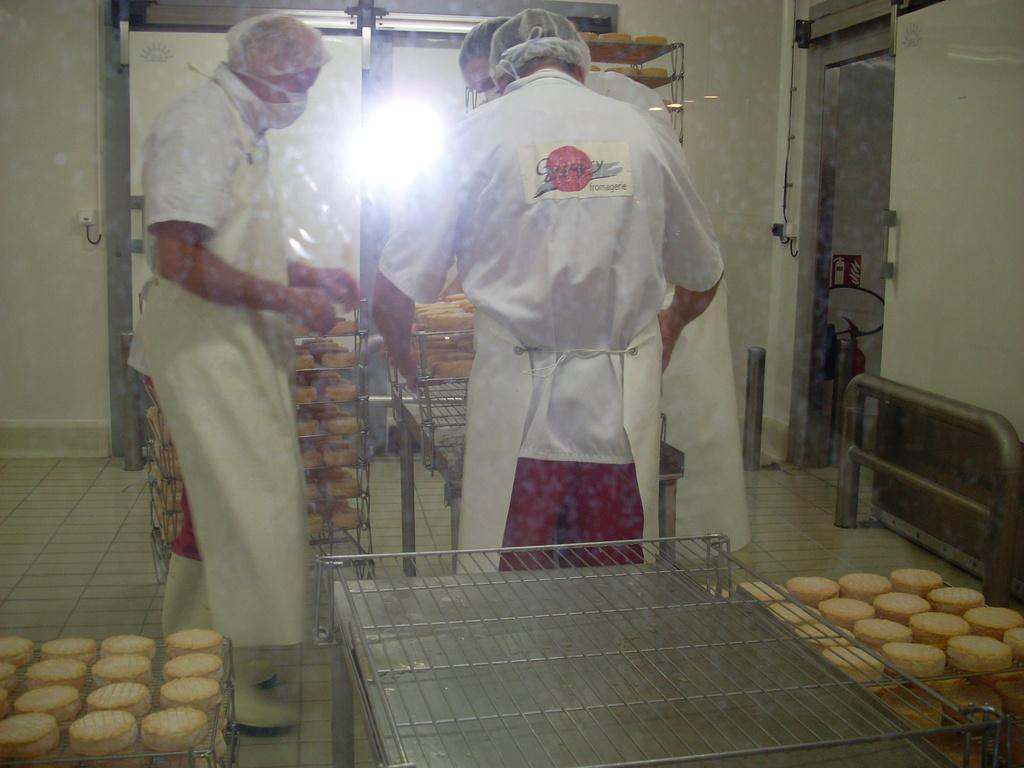In one or two sentences, can you explain what this image depicts? In this picture there are three men wearing white coats. At the bottom, there are trays with cookies. At the top right, there is a door to a wall. Behind the persons, there are some more trays with cookies. 